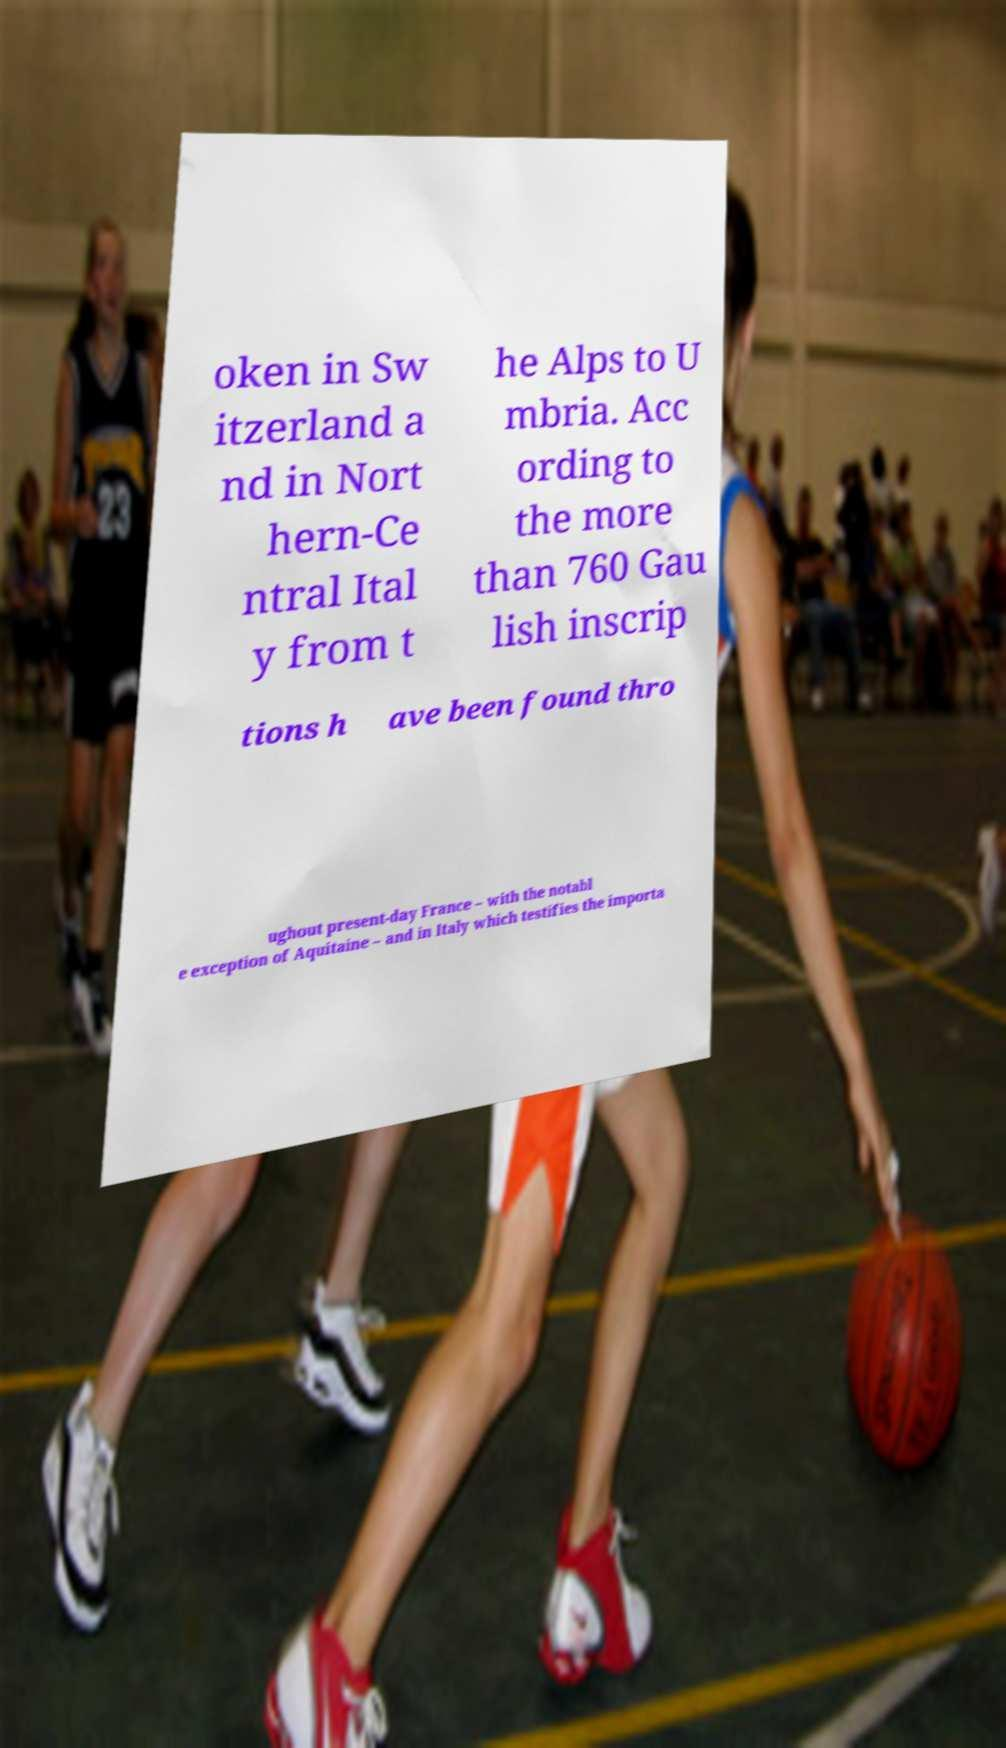For documentation purposes, I need the text within this image transcribed. Could you provide that? oken in Sw itzerland a nd in Nort hern-Ce ntral Ital y from t he Alps to U mbria. Acc ording to the more than 760 Gau lish inscrip tions h ave been found thro ughout present-day France – with the notabl e exception of Aquitaine – and in Italy which testifies the importa 